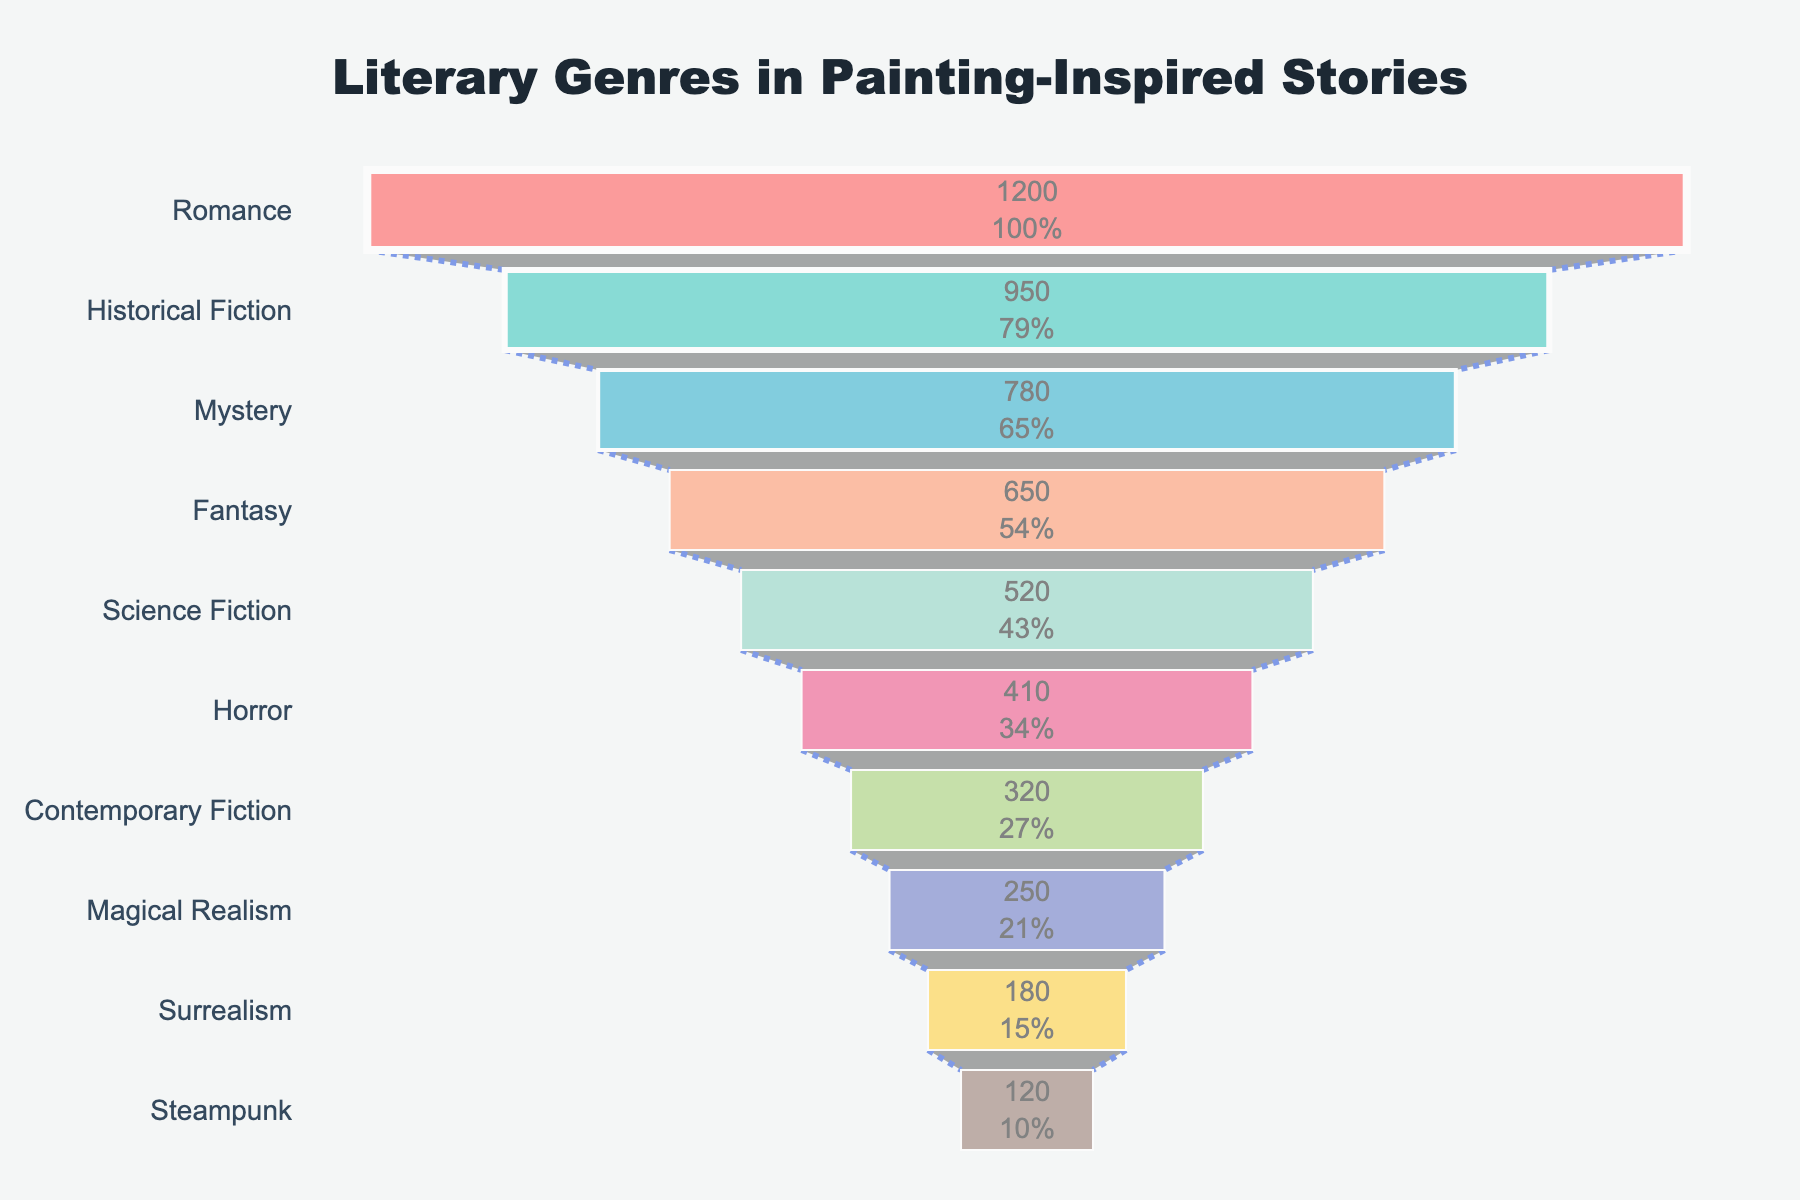What is the most popular genre in the chart? The most popular genre is indicated at the top of the funnel and it has the widest bar. It is "Romance" with 1200 stories.
Answer: Romance How many genres have more than 500 stories? To answer this, we look at the bars with more than 500 stories: "Romance," "Historical Fiction," "Mystery," "Fantasy," and "Science Fiction." This accounts for five genres.
Answer: Five What is the combined number of stories for "Historical Fiction" and "Fantasy"? Add the stories of "Historical Fiction" (950) and "Fantasy" (650), giving us 950 + 650 = 1600.
Answer: 1600 Which genre experiences the biggest drop in the number of stories compared to its predecessor? The biggest drop is between genres with the most significant differences in story counts: "Romance" (1200) to "Historical Fiction" (950), a drop of 250 stories.
Answer: Historical Fiction from Romance List the genres that have less than 400 stories. By inspecting the genres with story counts less than 400, we identify "Horror" (410) as just above, so it’s excluded. "Contemporary Fiction" (320), "Magical Realism" (250), "Surrealism" (180), and "Steampunk" (120) are all under 400 stories.
Answer: Contemporary Fiction, Magical Realism, Surrealism, Steampunk Which genre has the smallest percentage in the funnel? The smallest percentage is represented by the narrowest bottom bar in the funnel. "Steampunk" has 120 stories, making it the smallest percentage.
Answer: Steampunk How many genres have over 1000 stories in total when combined? Add the stories for "Romance" (1200) and "Historical Fiction" (950), both having more than 1000 stories individually. When combined, they sum to more than 1000.
Answer: Two What is the total number of stories for all genres combined in the funnel chart? Add up all the genre story counts: 1200 + 950 + 780 + 650 + 520 + 410 + 320 + 250 + 180 + 120. This totals 5380 stories.
Answer: 5380 Compare "Mystery" and "Horror" in terms of the number of stories. Which one has more and by how many? "Mystery" has 780 stories while "Horror" has 410 stories. Thus, 780 - 410 = 370 more stories for "Mystery."
Answer: Mystery has 370 more Which genre has a similar number of stories as "Science Fiction"? By comparing the numbers, "Horror" with 410 stories is closest to "Science Fiction" with 520 stories, having a difference of 110 stories. None has an exact match, but Horror is relatively close.
Answer: Horror 